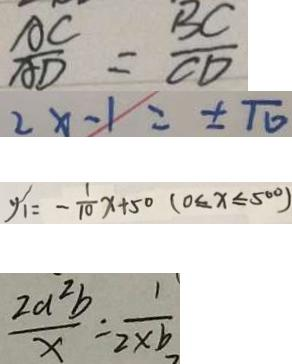<formula> <loc_0><loc_0><loc_500><loc_500>\frac { A C } { A D } = \frac { B C } { C D } 
 2 x - 1 = \pm \pi 
 y _ { 1 } = - \frac { 1 } { 1 0 } x + 5 0 ( 0 \leq x \leq 5 0 0 ) 
 \frac { 2 a ^ { 2 } b } { x } = \frac { 1 } { 2 \times b }</formula> 